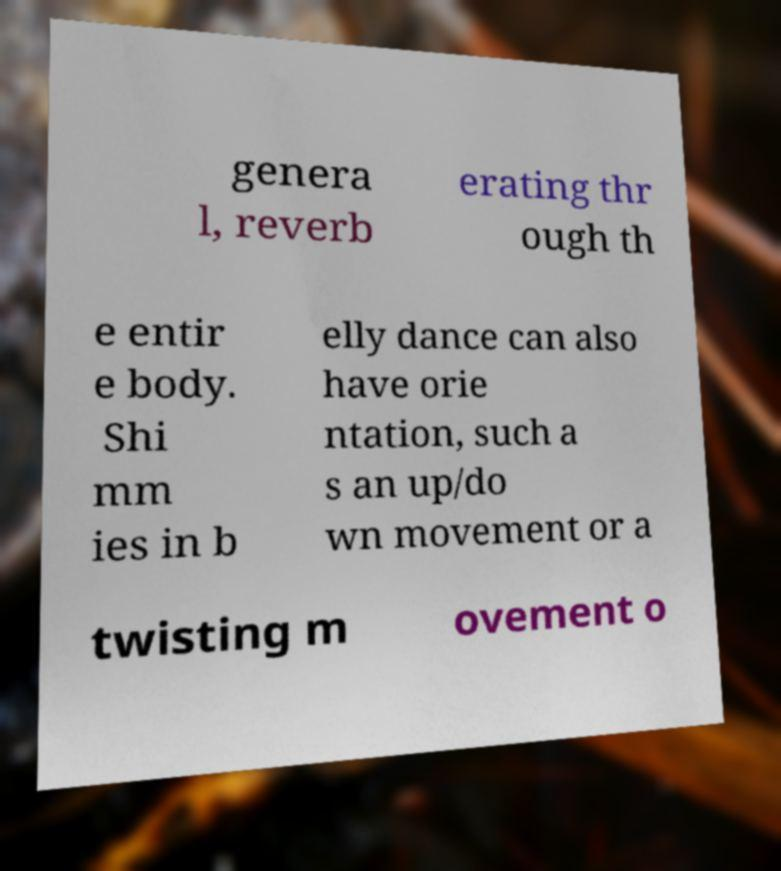I need the written content from this picture converted into text. Can you do that? genera l, reverb erating thr ough th e entir e body. Shi mm ies in b elly dance can also have orie ntation, such a s an up/do wn movement or a twisting m ovement o 